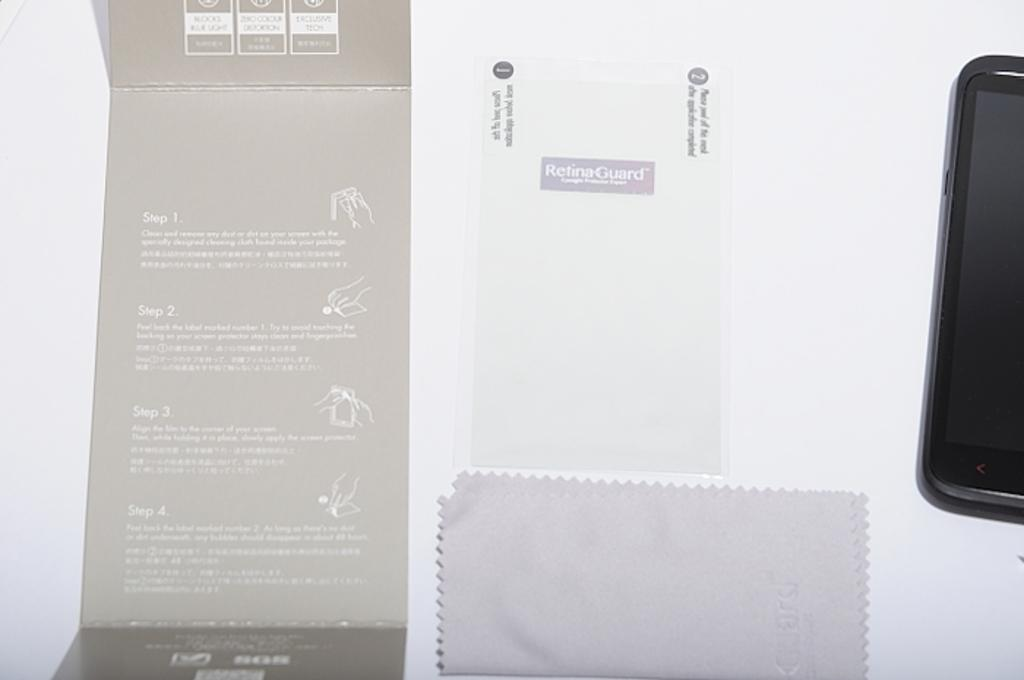<image>
Offer a succinct explanation of the picture presented. Instructions for cleaning a smart phone that include Steps 1, 2, 3, 4, and 5. 